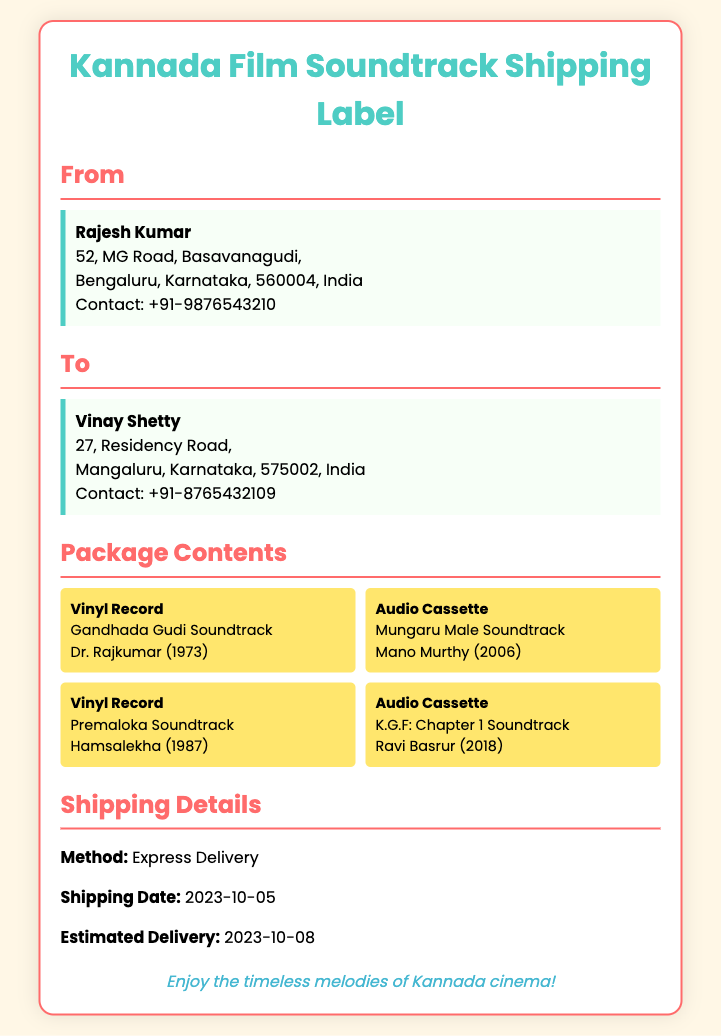What is the sender's name? The sender's name is provided in the "From" section on the shipping label.
Answer: Rajesh Kumar What is the recipient's address? The recipient's address is part of the "To" section on the shipping label.
Answer: 27, Residency Road, Mangaluru, Karnataka, 575002, India What is the contact number of the recipient? The contact number for the recipient is included in the "To" section on the shipping label.
Answer: +91-8765432109 What soundtrack is included on vinyl? The itemized list in the "Package Contents" details the soundtracks.
Answer: Gandhada Gudi Soundtrack When is the estimated delivery date? The estimated delivery date is mentioned in the "Shipping Details" section of the label.
Answer: 2023-10-08 What shipping method is used? The shipping method is specified in the "Shipping Details" section of the document.
Answer: Express Delivery How many items are listed in the package contents? The number of items can be determined by counting the entries under the "Package Contents" section.
Answer: 4 What year was the Mungaru Male soundtrack released? The year of release is stated in the description of the "Audio Cassette" for Mungaru Male.
Answer: 2006 Which film features the soundtrack composed by Hamsalekha? The film name is found in the description of the vinyl record listed in the package contents.
Answer: Premaloka 